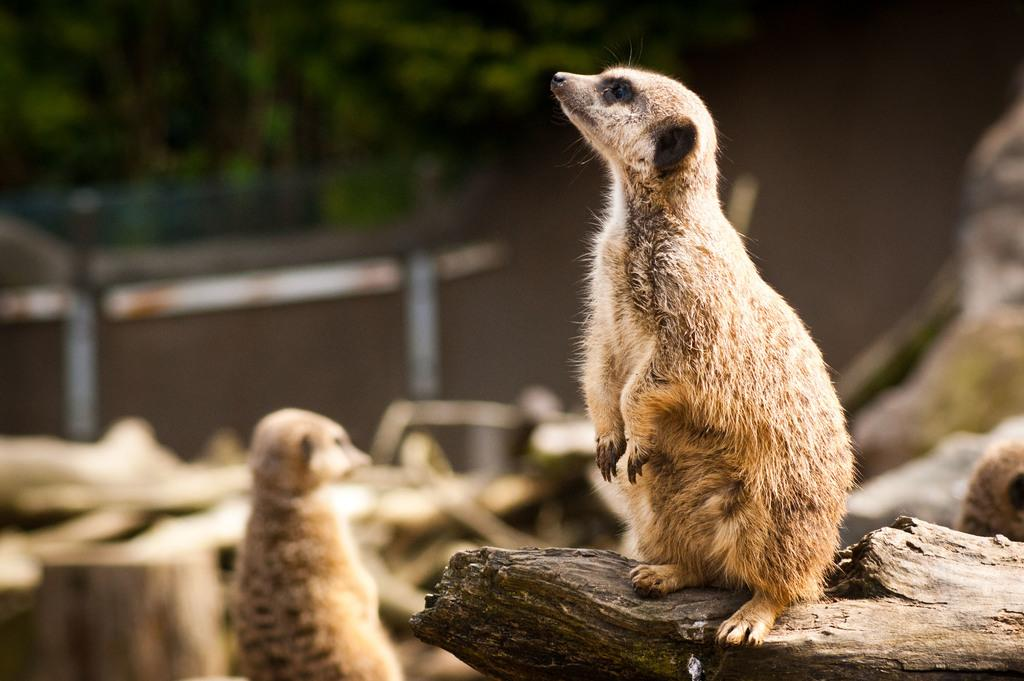What type of living organisms are present in the image? There are animals in the image. Can you describe the position of one of the animals? One of the animals is seated on tree bark. What color are the animals in the image? The animals are brown in color. What type of drum can be seen being played by one of the animals in the image? There is no drum present in the image; the animals are seated on tree bark. Can you describe the thread used to create the cobweb visible in the image? There is no cobweb present in the image, so it is not possible to describe the thread used to create it. 